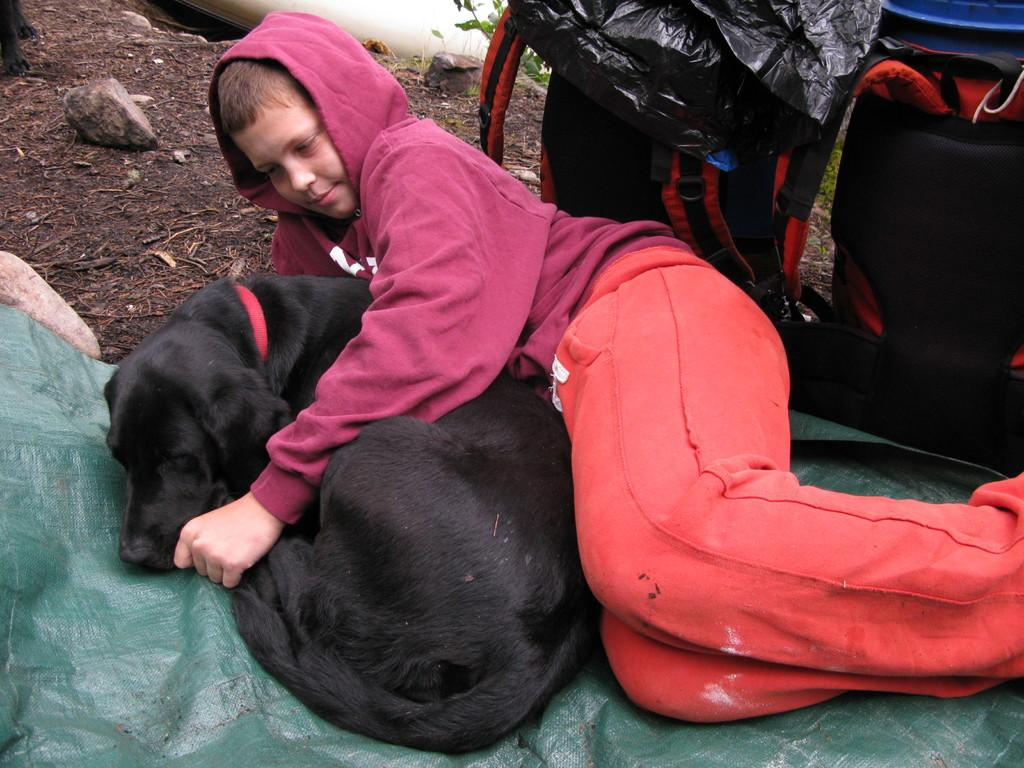Who is the main subject in the picture? There is a boy in the picture. What is the boy looking at? The boy is looking at a dog. Where is the dog positioned in relation to the boy? The dog is beside the boy. What can be seen on the right side of the image? There are bags on the right side of the image. What is present in the top left side of the image? There are stones on the top left side of the image. How many passengers are visible in the image? There are no passengers present in the image; it features a boy and a dog. What type of debt is being discussed in the image? There is no discussion of debt in the image; it focuses on the boy and the dog. 